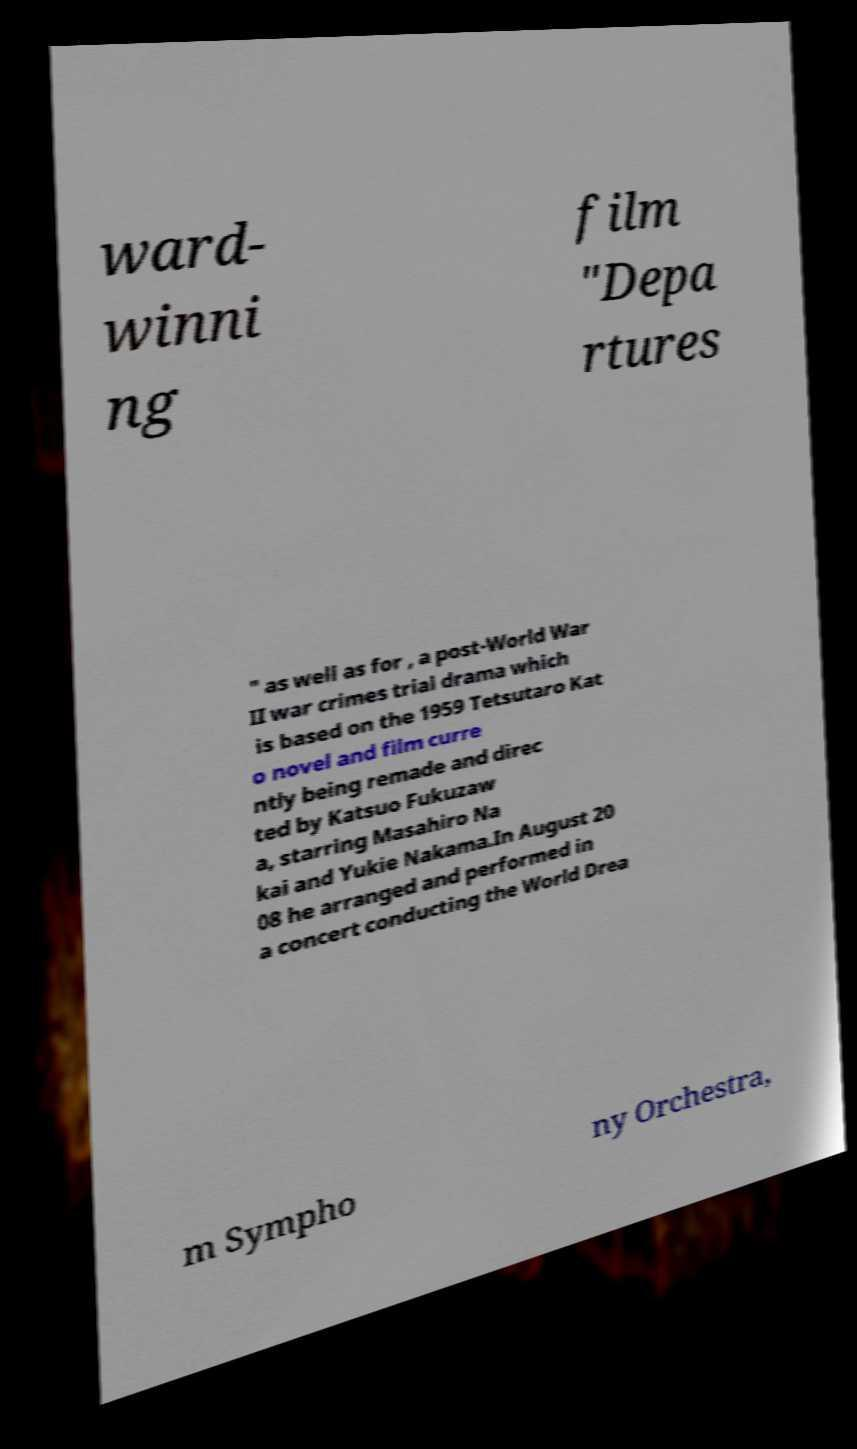Could you extract and type out the text from this image? ward- winni ng film "Depa rtures " as well as for , a post-World War II war crimes trial drama which is based on the 1959 Tetsutaro Kat o novel and film curre ntly being remade and direc ted by Katsuo Fukuzaw a, starring Masahiro Na kai and Yukie Nakama.In August 20 08 he arranged and performed in a concert conducting the World Drea m Sympho ny Orchestra, 